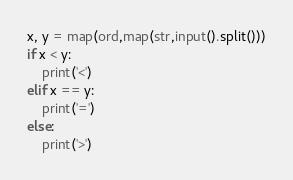Convert code to text. <code><loc_0><loc_0><loc_500><loc_500><_Python_>x, y = map(ord,map(str,input().split()))
if x < y:
    print('<')
elif x == y:
    print('=')
else:
    print('>')</code> 